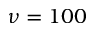<formula> <loc_0><loc_0><loc_500><loc_500>\nu = 1 0 0</formula> 